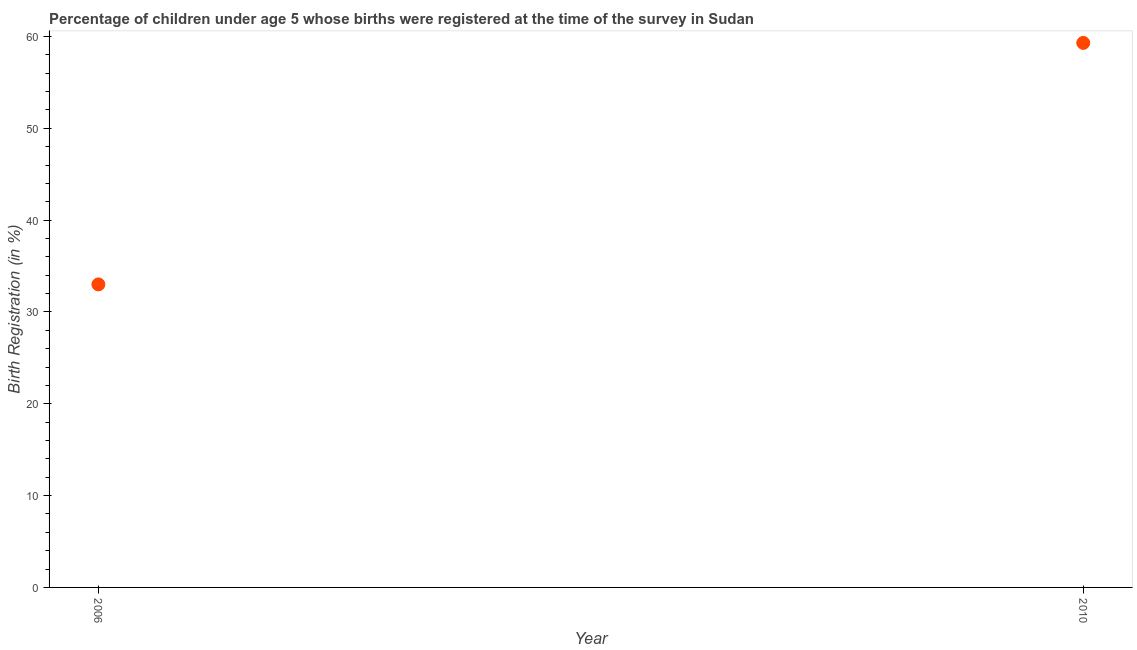Across all years, what is the maximum birth registration?
Your answer should be compact. 59.3. Across all years, what is the minimum birth registration?
Your response must be concise. 33. In which year was the birth registration minimum?
Make the answer very short. 2006. What is the sum of the birth registration?
Your response must be concise. 92.3. What is the difference between the birth registration in 2006 and 2010?
Provide a short and direct response. -26.3. What is the average birth registration per year?
Your answer should be compact. 46.15. What is the median birth registration?
Provide a short and direct response. 46.15. In how many years, is the birth registration greater than 14 %?
Ensure brevity in your answer.  2. Do a majority of the years between 2006 and 2010 (inclusive) have birth registration greater than 8 %?
Ensure brevity in your answer.  Yes. What is the ratio of the birth registration in 2006 to that in 2010?
Your answer should be compact. 0.56. How many years are there in the graph?
Make the answer very short. 2. What is the difference between two consecutive major ticks on the Y-axis?
Make the answer very short. 10. What is the title of the graph?
Your answer should be compact. Percentage of children under age 5 whose births were registered at the time of the survey in Sudan. What is the label or title of the Y-axis?
Your answer should be compact. Birth Registration (in %). What is the Birth Registration (in %) in 2010?
Make the answer very short. 59.3. What is the difference between the Birth Registration (in %) in 2006 and 2010?
Offer a terse response. -26.3. What is the ratio of the Birth Registration (in %) in 2006 to that in 2010?
Provide a succinct answer. 0.56. 